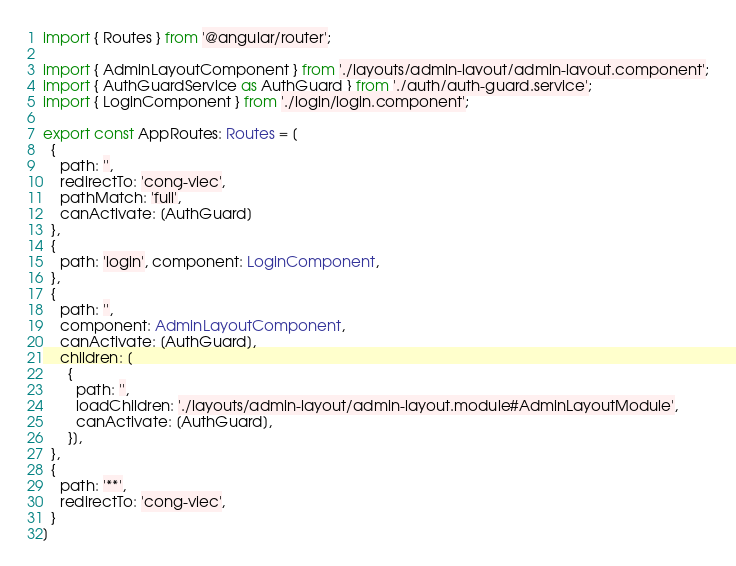Convert code to text. <code><loc_0><loc_0><loc_500><loc_500><_TypeScript_>import { Routes } from '@angular/router';

import { AdminLayoutComponent } from './layouts/admin-layout/admin-layout.component';
import { AuthGuardService as AuthGuard } from './auth/auth-guard.service';
import { LoginComponent } from './login/login.component';

export const AppRoutes: Routes = [
  {
    path: '',
    redirectTo: 'cong-viec',
    pathMatch: 'full',
    canActivate: [AuthGuard]
  },
  {
    path: 'login', component: LoginComponent,
  },
  {
    path: '',
    component: AdminLayoutComponent,
    canActivate: [AuthGuard],
    children: [
      {
        path: '',
        loadChildren: './layouts/admin-layout/admin-layout.module#AdminLayoutModule',
        canActivate: [AuthGuard],
      }],
  },
  {
    path: '**',
    redirectTo: 'cong-viec',
  }
]
</code> 